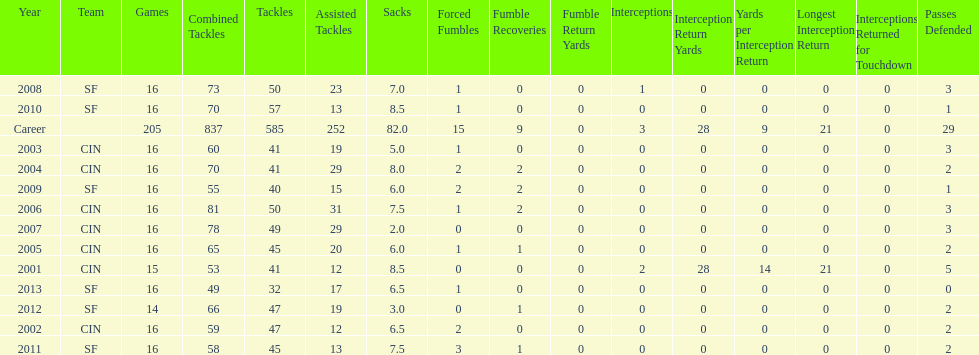In how many successive years were there 20 or more assisted tackles? 5. 